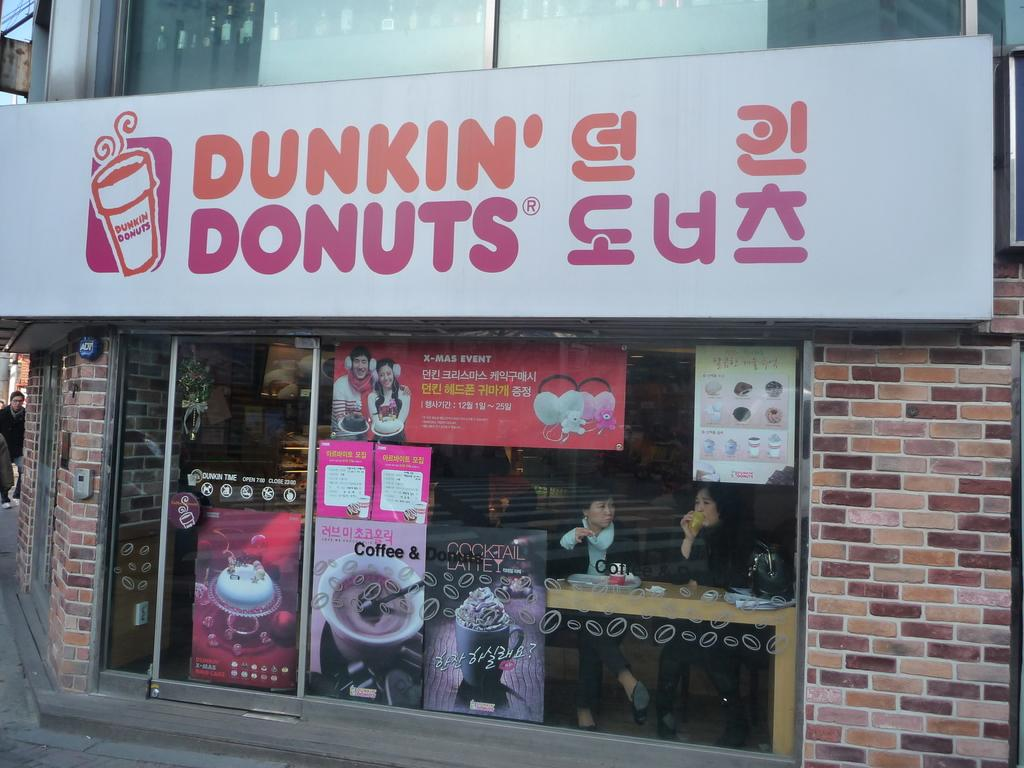What is on the building in the image? There is a hoarding on a building in the image. What is on the glass ball and glass door? There are posters on a glass ball and glass door. Can you see any people in the image? Yes, a person is visible in the image, and people are visible through the glass. What objects can be seen through the glass? A bag and a table are visible through the glass. Can you see the writer of the posters in the image? There is no information about the writer of the posters in the image, and no person is specifically identified as the writer. Are there any people kissing in the image? There is no indication of any kissing in the image; it only shows a person and people visible through the glass. 